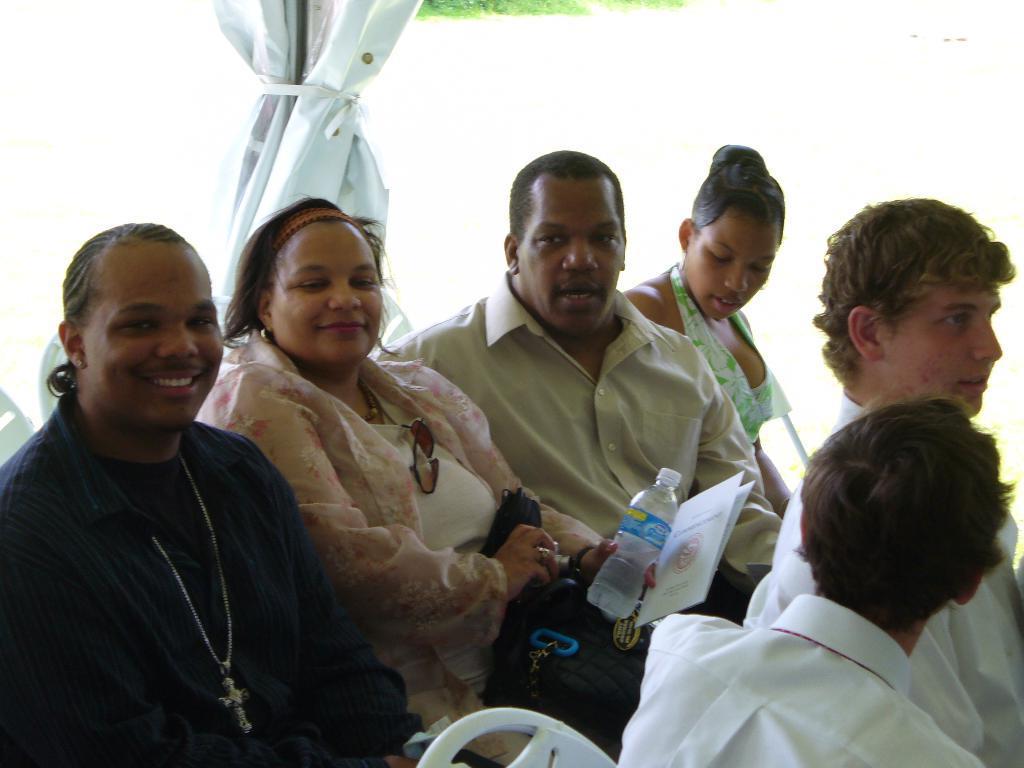Can you describe this image briefly? In the background we can see an object. In this picture we can see people sitting on the chairs. We can see a woman is holding a bottle and car. We can see a bag. She is smiling. 